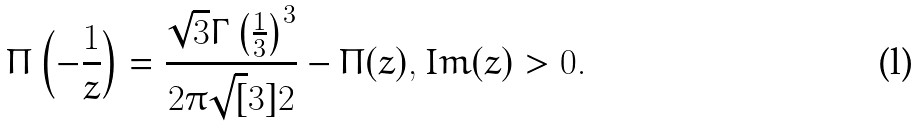<formula> <loc_0><loc_0><loc_500><loc_500>\Pi \left ( - \frac { 1 } { z } \right ) = \frac { \sqrt { 3 } \Gamma \left ( \frac { 1 } { 3 } \right ) ^ { 3 } } { 2 \pi \sqrt { [ } 3 ] { 2 } } - \Pi ( z ) , I m ( z ) > 0 .</formula> 